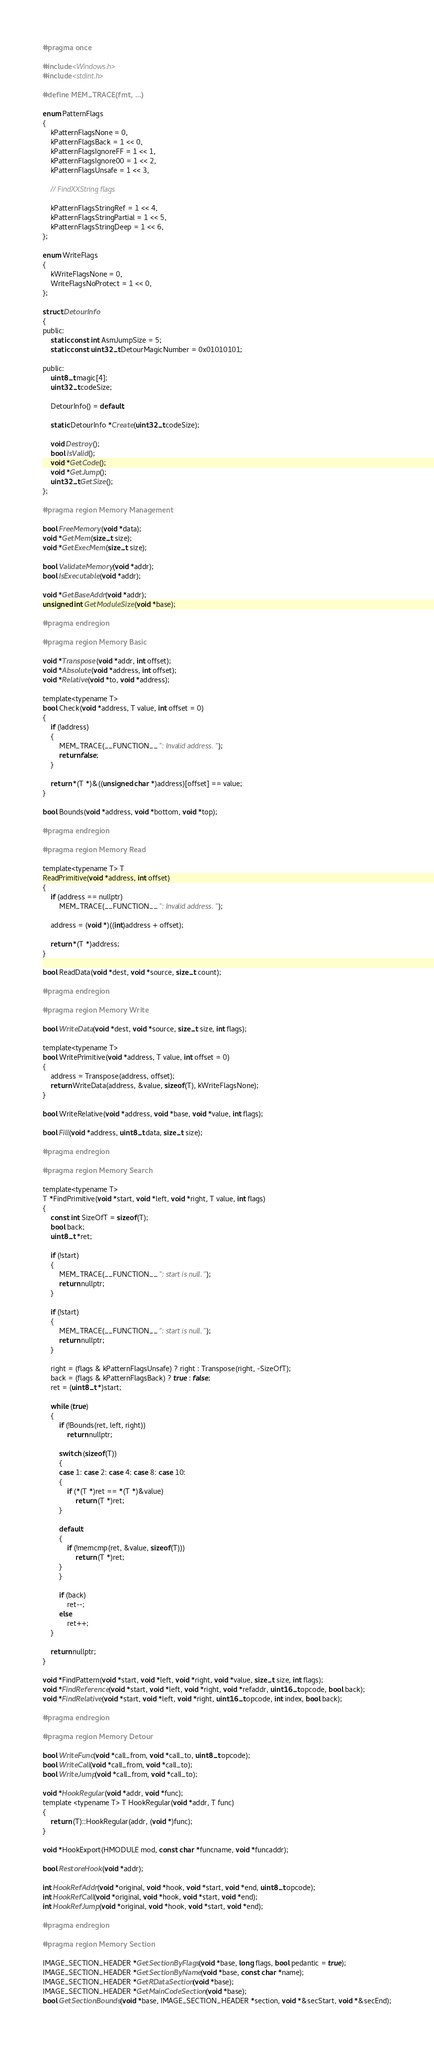<code> <loc_0><loc_0><loc_500><loc_500><_C_>#pragma once

#include <Windows.h>
#include <stdint.h>

#define MEM_TRACE(fmt, ...)

enum PatternFlags
{
	kPatternFlagsNone = 0,
	kPatternFlagsBack = 1 << 0,
	kPatternFlagsIgnoreFF = 1 << 1,
	kPatternFlagsIgnore00 = 1 << 2,
	kPatternFlagsUnsafe = 1 << 3,

	// FindXXString flags

	kPatternFlagsStringRef = 1 << 4,
	kPatternFlagsStringPartial = 1 << 5,
	kPatternFlagsStringDeep = 1 << 6,
};

enum WriteFlags
{
	kWriteFlagsNone = 0,
	WriteFlagsNoProtect = 1 << 0,
};

struct DetourInfo
{
public:
	static const int AsmJumpSize = 5;
	static const uint32_t DetourMagicNumber = 0x01010101;

public:
	uint8_t magic[4];
	uint32_t codeSize;

	DetourInfo() = default;

	static DetourInfo *Create(uint32_t codeSize);

	void Destroy();
	bool IsValid();
	void *GetCode();
	void *GetJump();
	uint32_t GetSize();
};

#pragma region Memory Management

bool FreeMemory(void *data);
void *GetMem(size_t size);
void *GetExecMem(size_t size);

bool ValidateMemory(void *addr);
bool IsExecutable(void *addr);

void *GetBaseAddr(void *addr);
unsigned int GetModuleSize(void *base);

#pragma endregion

#pragma region Memory Basic

void *Transpose(void *addr, int offset);
void *Absolute(void *address, int offset);
void *Relative(void *to, void *address);

template<typename T>
bool Check(void *address, T value, int offset = 0)
{
	if (!address)
	{
		MEM_TRACE(__FUNCTION__ ": Invalid address.");
		return false;
	}

	return *(T *)&((unsigned char *)address)[offset] == value;
}

bool Bounds(void *address, void *bottom, void *top);

#pragma endregion

#pragma region Memory Read

template<typename T> T
ReadPrimitive(void *address, int offset)
{
	if (address == nullptr)
		MEM_TRACE(__FUNCTION__ ": Invalid address.");

	address = (void *)((int)address + offset);

	return *(T *)address;
}

bool ReadData(void *dest, void *source, size_t count);

#pragma endregion

#pragma region Memory Write

bool WriteData(void *dest, void *source, size_t size, int flags);

template<typename T>
bool WritePrimitive(void *address, T value, int offset = 0)
{
	address = Transpose(address, offset);
	return WriteData(address, &value, sizeof(T), kWriteFlagsNone);
}

bool WriteRelative(void *address, void *base, void *value, int flags);

bool Fill(void *address, uint8_t data, size_t size);

#pragma endregion

#pragma region Memory Search

template<typename T>
T *FindPrimitive(void *start, void *left, void *right, T value, int flags)
{
	const int SizeOfT = sizeof(T);
	bool back;
	uint8_t *ret;

	if (!start)
	{
		MEM_TRACE(__FUNCTION__ ": start is null.");
		return nullptr;
	}

	if (!start)
	{
		MEM_TRACE(__FUNCTION__ ": start is null.");
		return nullptr;
	}

	right = (flags & kPatternFlagsUnsafe) ? right : Transpose(right, -SizeOfT);
	back = (flags & kPatternFlagsBack) ? true : false;
	ret = (uint8_t *)start;

	while (true)
	{
		if (!Bounds(ret, left, right))
			return nullptr;

		switch (sizeof(T))
		{
		case 1: case 2: case 4: case 8: case 10:
		{
			if (*(T *)ret == *(T *)&value)
				return (T *)ret;
		}

		default:
		{
			if (!memcmp(ret, &value, sizeof(T)))
				return (T *)ret;
		}
		}

		if (back)
			ret--;
		else
			ret++;
	}

	return nullptr;
}

void *FindPattern(void *start, void *left, void *right, void *value, size_t size, int flags);
void *FindReference(void *start, void *left, void *right, void *refaddr, uint16_t opcode, bool back);
void *FindRelative(void *start, void *left, void *right, uint16_t opcode, int index, bool back);

#pragma endregion

#pragma region Memory Detour

bool WriteFunc(void *call_from, void *call_to, uint8_t opcode);
bool WriteCall(void *call_from, void *call_to);
bool WriteJump(void *call_from, void *call_to);

void *HookRegular(void *addr, void *func);
template <typename T> T HookRegular(void *addr, T func)
{
	return (T)::HookRegular(addr, (void *)func);
}

void *HookExport(HMODULE mod, const char *funcname, void *funcaddr);

bool RestoreHook(void *addr);

int HookRefAddr(void *original, void *hook, void *start, void *end, uint8_t opcode);
int HookRefCall(void *original, void *hook, void *start, void *end);
int HookRefJump(void *original, void *hook, void *start, void *end);

#pragma endregion

#pragma region Memory Section

IMAGE_SECTION_HEADER *GetSectionByFlags(void *base, long flags, bool pedantic = true);
IMAGE_SECTION_HEADER *GetSectionByName(void *base, const char *name);
IMAGE_SECTION_HEADER *GetRDataSection(void *base);
IMAGE_SECTION_HEADER *GetMainCodeSection(void *base);
bool GetSectionBounds(void *base, IMAGE_SECTION_HEADER *section, void *&secStart, void *&secEnd);</code> 